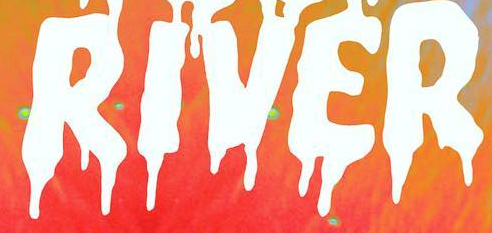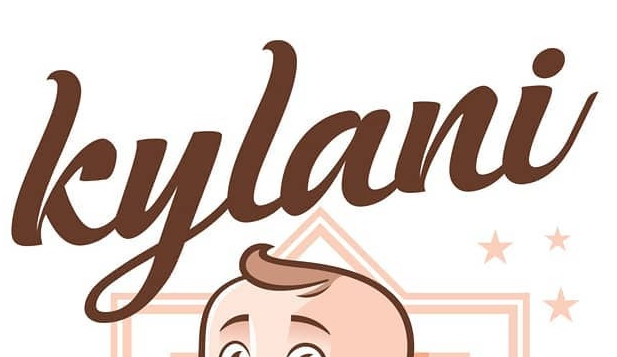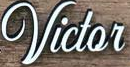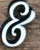What words can you see in these images in sequence, separated by a semicolon? RIVER; kylani; Victor; & 